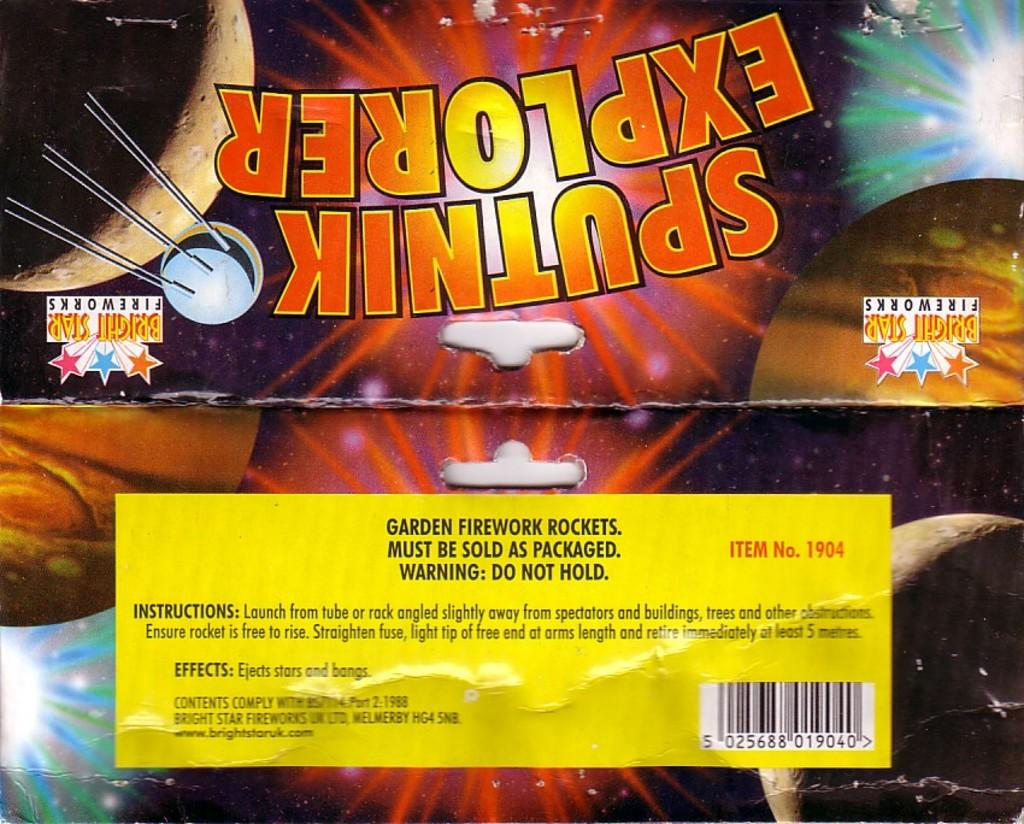<image>
Provide a brief description of the given image. Spuntik explorer fireworks wrapper in bright colors with a yellow label on the back. 